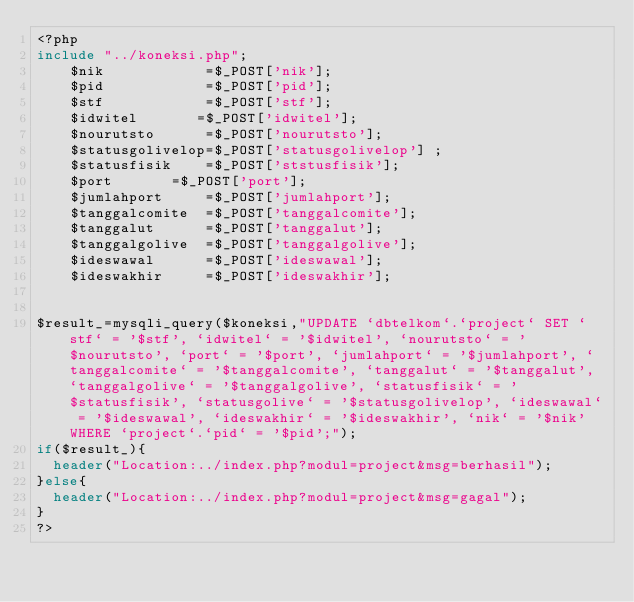<code> <loc_0><loc_0><loc_500><loc_500><_PHP_><?php 
include "../koneksi.php";
   	$nik            =$_POST['nik'];
    $pid            =$_POST['pid'];
    $stf            =$_POST['stf'];
    $idwitel       =$_POST['idwitel'];
    $nourutsto      =$_POST['nourutsto'];
    $statusgolivelop=$_POST['statusgolivelop'] ;
    $statusfisik    =$_POST['ststusfisik'];
    $port		    =$_POST['port'];
    $jumlahport	    =$_POST['jumlahport'];
    $tanggalcomite  =$_POST['tanggalcomite'];
    $tanggalut      =$_POST['tanggalut'];
    $tanggalgolive  =$_POST['tanggalgolive'];
    $ideswawal      =$_POST['ideswawal'];
    $ideswakhir     =$_POST['ideswakhir'];


$result_=mysqli_query($koneksi,"UPDATE `dbtelkom`.`project` SET `stf` = '$stf', `idwitel` = '$idwitel', `nourutsto` = '$nourutsto', `port` = '$port', `jumlahport` = '$jumlahport', `tanggalcomite` = '$tanggalcomite', `tanggalut` = '$tanggalut', `tanggalgolive` = '$tanggalgolive', `statusfisik` = '$statusfisik', `statusgolive` = '$statusgolivelop', `ideswawal` = '$ideswawal', `ideswakhir` = '$ideswakhir', `nik` = '$nik' WHERE `project`.`pid` = '$pid';");
if($result_){
	header("Location:../index.php?modul=project&msg=berhasil");
}else{
	header("Location:../index.php?modul=project&msg=gagal");
}
?></code> 